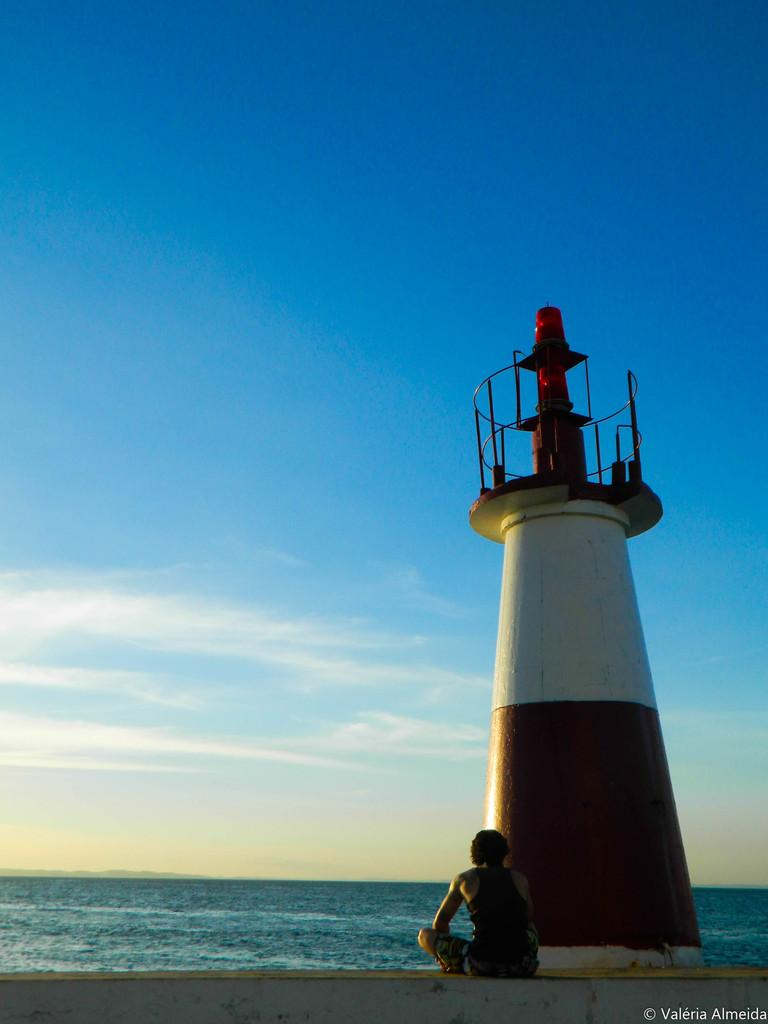What is the main structure in the image? There is a lighthouse in the image. What is the person in the image doing? There is a person sitting in the image. What can be seen in the background of the image? There is water, clouds, and the sky visible in the background of the image. Where is the sheep that your dad brought in the image? There is no sheep or mention of a dad in the image. 